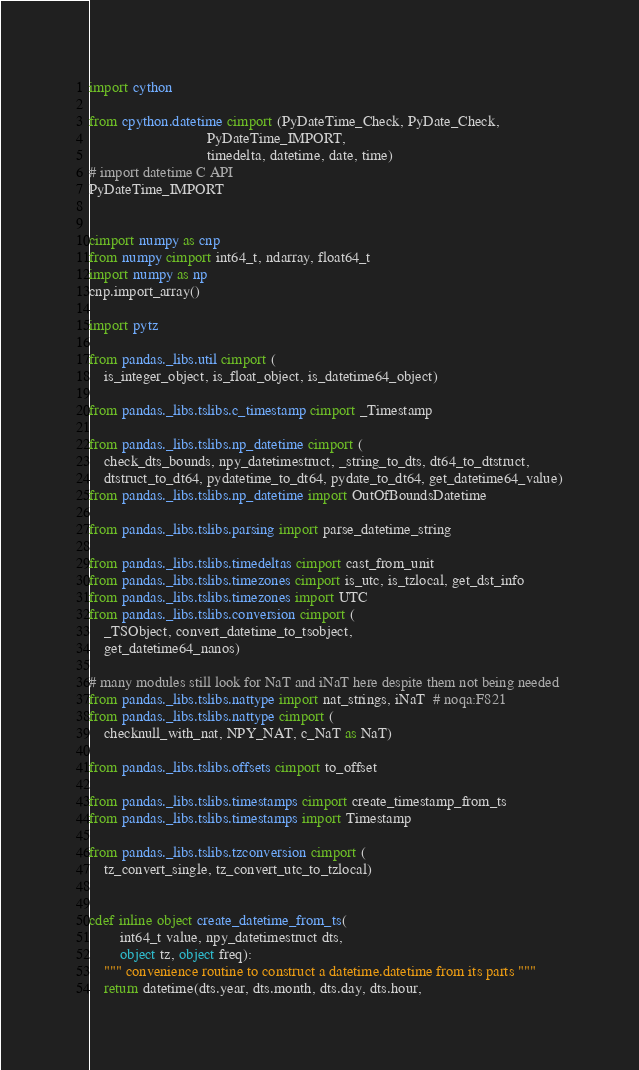Convert code to text. <code><loc_0><loc_0><loc_500><loc_500><_Cython_>import cython

from cpython.datetime cimport (PyDateTime_Check, PyDate_Check,
                               PyDateTime_IMPORT,
                               timedelta, datetime, date, time)
# import datetime C API
PyDateTime_IMPORT


cimport numpy as cnp
from numpy cimport int64_t, ndarray, float64_t
import numpy as np
cnp.import_array()

import pytz

from pandas._libs.util cimport (
    is_integer_object, is_float_object, is_datetime64_object)

from pandas._libs.tslibs.c_timestamp cimport _Timestamp

from pandas._libs.tslibs.np_datetime cimport (
    check_dts_bounds, npy_datetimestruct, _string_to_dts, dt64_to_dtstruct,
    dtstruct_to_dt64, pydatetime_to_dt64, pydate_to_dt64, get_datetime64_value)
from pandas._libs.tslibs.np_datetime import OutOfBoundsDatetime

from pandas._libs.tslibs.parsing import parse_datetime_string

from pandas._libs.tslibs.timedeltas cimport cast_from_unit
from pandas._libs.tslibs.timezones cimport is_utc, is_tzlocal, get_dst_info
from pandas._libs.tslibs.timezones import UTC
from pandas._libs.tslibs.conversion cimport (
    _TSObject, convert_datetime_to_tsobject,
    get_datetime64_nanos)

# many modules still look for NaT and iNaT here despite them not being needed
from pandas._libs.tslibs.nattype import nat_strings, iNaT  # noqa:F821
from pandas._libs.tslibs.nattype cimport (
    checknull_with_nat, NPY_NAT, c_NaT as NaT)

from pandas._libs.tslibs.offsets cimport to_offset

from pandas._libs.tslibs.timestamps cimport create_timestamp_from_ts
from pandas._libs.tslibs.timestamps import Timestamp

from pandas._libs.tslibs.tzconversion cimport (
    tz_convert_single, tz_convert_utc_to_tzlocal)


cdef inline object create_datetime_from_ts(
        int64_t value, npy_datetimestruct dts,
        object tz, object freq):
    """ convenience routine to construct a datetime.datetime from its parts """
    return datetime(dts.year, dts.month, dts.day, dts.hour,</code> 